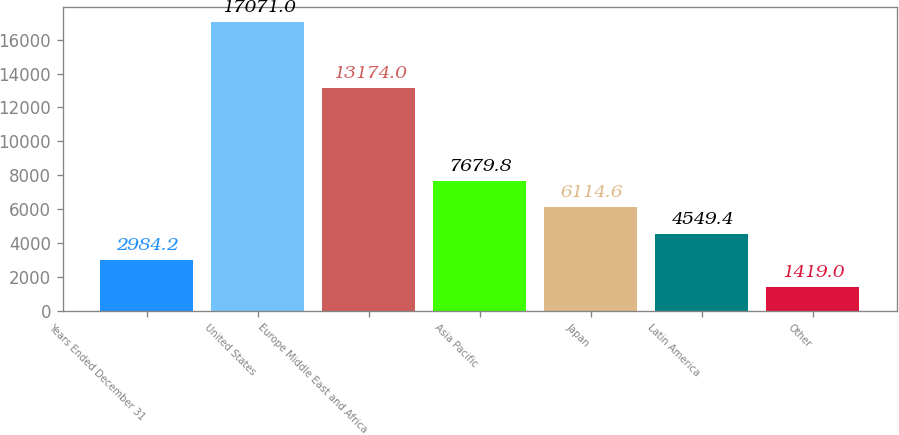Convert chart to OTSL. <chart><loc_0><loc_0><loc_500><loc_500><bar_chart><fcel>Years Ended December 31<fcel>United States<fcel>Europe Middle East and Africa<fcel>Asia Pacific<fcel>Japan<fcel>Latin America<fcel>Other<nl><fcel>2984.2<fcel>17071<fcel>13174<fcel>7679.8<fcel>6114.6<fcel>4549.4<fcel>1419<nl></chart> 